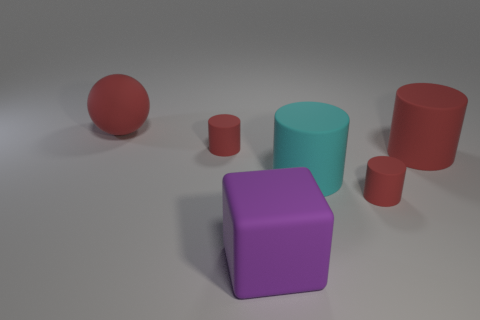Are there any other things that have the same color as the large sphere? Yes, there is a smaller sphere to the right with the same shade of red as the large sphere. 